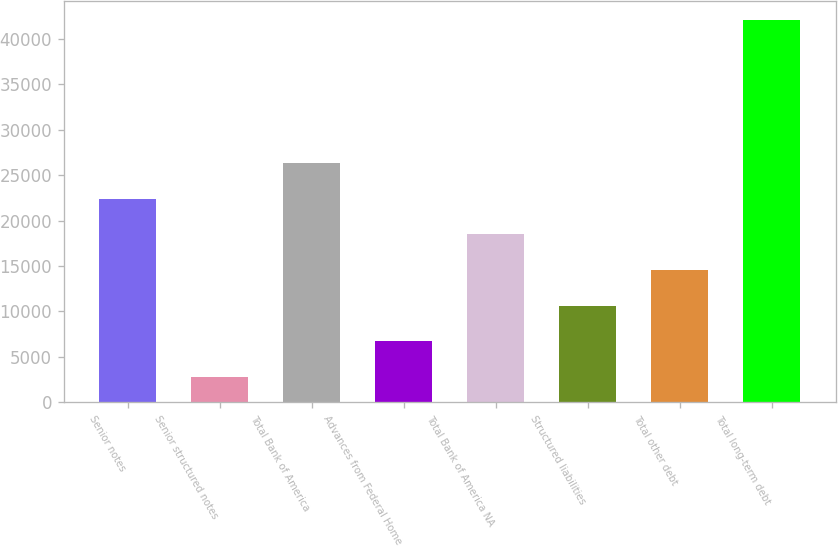<chart> <loc_0><loc_0><loc_500><loc_500><bar_chart><fcel>Senior notes<fcel>Senior structured notes<fcel>Total Bank of America<fcel>Advances from Federal Home<fcel>Total Bank of America NA<fcel>Structured liabilities<fcel>Total other debt<fcel>Total long-term debt<nl><fcel>22403<fcel>2749<fcel>26333.8<fcel>6679.8<fcel>18472.2<fcel>10610.6<fcel>14541.4<fcel>42057<nl></chart> 